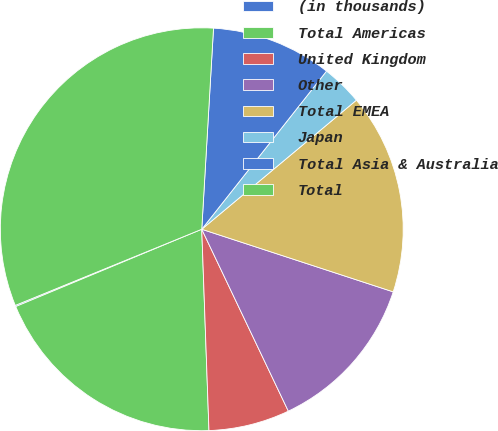<chart> <loc_0><loc_0><loc_500><loc_500><pie_chart><fcel>(in thousands)<fcel>Total Americas<fcel>United Kingdom<fcel>Other<fcel>Total EMEA<fcel>Japan<fcel>Total Asia & Australia<fcel>Total<nl><fcel>0.1%<fcel>19.3%<fcel>6.5%<fcel>12.9%<fcel>16.1%<fcel>3.3%<fcel>9.7%<fcel>32.1%<nl></chart> 